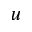<formula> <loc_0><loc_0><loc_500><loc_500>^ { u }</formula> 